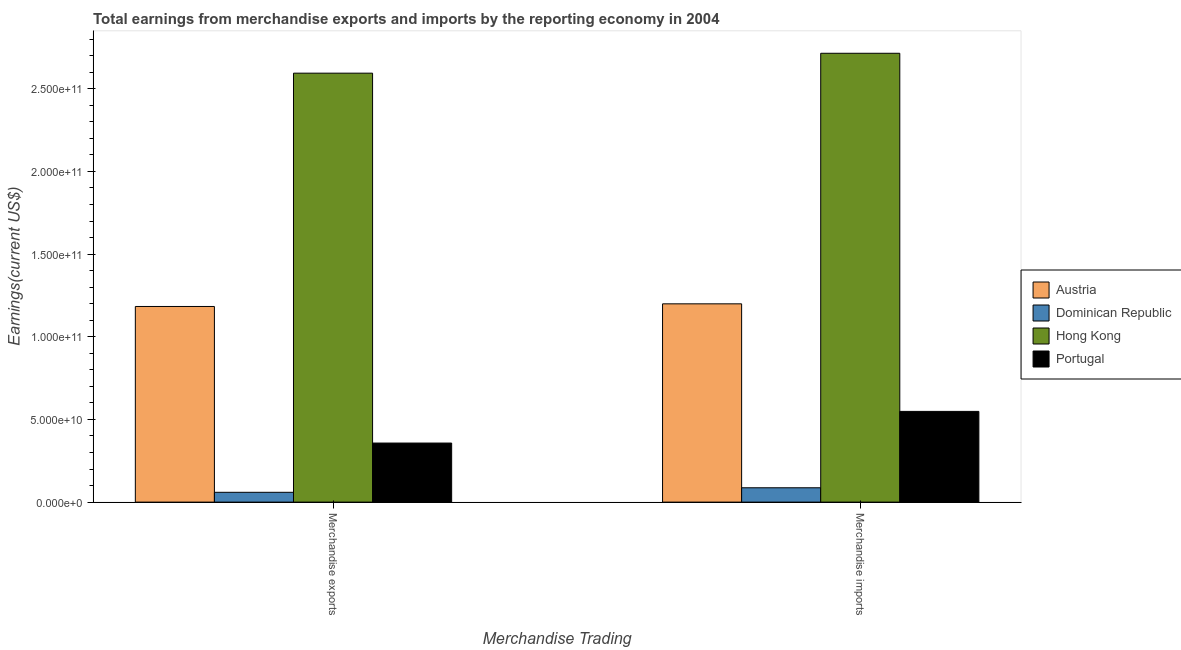Are the number of bars per tick equal to the number of legend labels?
Provide a succinct answer. Yes. How many bars are there on the 1st tick from the left?
Provide a short and direct response. 4. What is the label of the 1st group of bars from the left?
Offer a very short reply. Merchandise exports. What is the earnings from merchandise exports in Portugal?
Provide a succinct answer. 3.57e+1. Across all countries, what is the maximum earnings from merchandise exports?
Provide a short and direct response. 2.59e+11. Across all countries, what is the minimum earnings from merchandise exports?
Keep it short and to the point. 5.94e+09. In which country was the earnings from merchandise exports maximum?
Offer a terse response. Hong Kong. In which country was the earnings from merchandise imports minimum?
Give a very brief answer. Dominican Republic. What is the total earnings from merchandise exports in the graph?
Keep it short and to the point. 4.19e+11. What is the difference between the earnings from merchandise exports in Austria and that in Portugal?
Offer a very short reply. 8.26e+1. What is the difference between the earnings from merchandise exports in Hong Kong and the earnings from merchandise imports in Portugal?
Ensure brevity in your answer.  2.05e+11. What is the average earnings from merchandise imports per country?
Offer a very short reply. 1.14e+11. What is the difference between the earnings from merchandise exports and earnings from merchandise imports in Austria?
Your answer should be compact. -1.60e+09. What is the ratio of the earnings from merchandise imports in Austria to that in Dominican Republic?
Your answer should be compact. 13.82. Is the earnings from merchandise exports in Hong Kong less than that in Dominican Republic?
Keep it short and to the point. No. What does the 3rd bar from the left in Merchandise exports represents?
Keep it short and to the point. Hong Kong. What does the 3rd bar from the right in Merchandise exports represents?
Your answer should be very brief. Dominican Republic. How many bars are there?
Keep it short and to the point. 8. Are all the bars in the graph horizontal?
Offer a very short reply. No. Are the values on the major ticks of Y-axis written in scientific E-notation?
Offer a terse response. Yes. Does the graph contain grids?
Keep it short and to the point. No. Where does the legend appear in the graph?
Provide a short and direct response. Center right. What is the title of the graph?
Provide a succinct answer. Total earnings from merchandise exports and imports by the reporting economy in 2004. Does "Bahrain" appear as one of the legend labels in the graph?
Offer a terse response. No. What is the label or title of the X-axis?
Your answer should be very brief. Merchandise Trading. What is the label or title of the Y-axis?
Your answer should be very brief. Earnings(current US$). What is the Earnings(current US$) in Austria in Merchandise exports?
Your response must be concise. 1.18e+11. What is the Earnings(current US$) in Dominican Republic in Merchandise exports?
Your answer should be compact. 5.94e+09. What is the Earnings(current US$) in Hong Kong in Merchandise exports?
Provide a short and direct response. 2.59e+11. What is the Earnings(current US$) in Portugal in Merchandise exports?
Keep it short and to the point. 3.57e+1. What is the Earnings(current US$) in Austria in Merchandise imports?
Give a very brief answer. 1.20e+11. What is the Earnings(current US$) of Dominican Republic in Merchandise imports?
Provide a short and direct response. 8.68e+09. What is the Earnings(current US$) of Hong Kong in Merchandise imports?
Your answer should be very brief. 2.71e+11. What is the Earnings(current US$) in Portugal in Merchandise imports?
Offer a terse response. 5.49e+1. Across all Merchandise Trading, what is the maximum Earnings(current US$) in Austria?
Give a very brief answer. 1.20e+11. Across all Merchandise Trading, what is the maximum Earnings(current US$) in Dominican Republic?
Offer a very short reply. 8.68e+09. Across all Merchandise Trading, what is the maximum Earnings(current US$) in Hong Kong?
Ensure brevity in your answer.  2.71e+11. Across all Merchandise Trading, what is the maximum Earnings(current US$) of Portugal?
Provide a short and direct response. 5.49e+1. Across all Merchandise Trading, what is the minimum Earnings(current US$) in Austria?
Your response must be concise. 1.18e+11. Across all Merchandise Trading, what is the minimum Earnings(current US$) of Dominican Republic?
Offer a very short reply. 5.94e+09. Across all Merchandise Trading, what is the minimum Earnings(current US$) of Hong Kong?
Your answer should be very brief. 2.59e+11. Across all Merchandise Trading, what is the minimum Earnings(current US$) of Portugal?
Provide a succinct answer. 3.57e+1. What is the total Earnings(current US$) in Austria in the graph?
Your answer should be very brief. 2.38e+11. What is the total Earnings(current US$) in Dominican Republic in the graph?
Keep it short and to the point. 1.46e+1. What is the total Earnings(current US$) of Hong Kong in the graph?
Your response must be concise. 5.31e+11. What is the total Earnings(current US$) of Portugal in the graph?
Ensure brevity in your answer.  9.06e+1. What is the difference between the Earnings(current US$) in Austria in Merchandise exports and that in Merchandise imports?
Give a very brief answer. -1.60e+09. What is the difference between the Earnings(current US$) in Dominican Republic in Merchandise exports and that in Merchandise imports?
Offer a terse response. -2.74e+09. What is the difference between the Earnings(current US$) of Hong Kong in Merchandise exports and that in Merchandise imports?
Your response must be concise. -1.20e+1. What is the difference between the Earnings(current US$) of Portugal in Merchandise exports and that in Merchandise imports?
Keep it short and to the point. -1.91e+1. What is the difference between the Earnings(current US$) in Austria in Merchandise exports and the Earnings(current US$) in Dominican Republic in Merchandise imports?
Give a very brief answer. 1.10e+11. What is the difference between the Earnings(current US$) in Austria in Merchandise exports and the Earnings(current US$) in Hong Kong in Merchandise imports?
Your answer should be compact. -1.53e+11. What is the difference between the Earnings(current US$) in Austria in Merchandise exports and the Earnings(current US$) in Portugal in Merchandise imports?
Offer a terse response. 6.35e+1. What is the difference between the Earnings(current US$) of Dominican Republic in Merchandise exports and the Earnings(current US$) of Hong Kong in Merchandise imports?
Provide a short and direct response. -2.66e+11. What is the difference between the Earnings(current US$) of Dominican Republic in Merchandise exports and the Earnings(current US$) of Portugal in Merchandise imports?
Provide a short and direct response. -4.89e+1. What is the difference between the Earnings(current US$) of Hong Kong in Merchandise exports and the Earnings(current US$) of Portugal in Merchandise imports?
Your answer should be very brief. 2.05e+11. What is the average Earnings(current US$) in Austria per Merchandise Trading?
Ensure brevity in your answer.  1.19e+11. What is the average Earnings(current US$) in Dominican Republic per Merchandise Trading?
Your answer should be very brief. 7.31e+09. What is the average Earnings(current US$) in Hong Kong per Merchandise Trading?
Offer a terse response. 2.65e+11. What is the average Earnings(current US$) in Portugal per Merchandise Trading?
Offer a very short reply. 4.53e+1. What is the difference between the Earnings(current US$) of Austria and Earnings(current US$) of Dominican Republic in Merchandise exports?
Provide a short and direct response. 1.12e+11. What is the difference between the Earnings(current US$) of Austria and Earnings(current US$) of Hong Kong in Merchandise exports?
Ensure brevity in your answer.  -1.41e+11. What is the difference between the Earnings(current US$) in Austria and Earnings(current US$) in Portugal in Merchandise exports?
Offer a terse response. 8.26e+1. What is the difference between the Earnings(current US$) of Dominican Republic and Earnings(current US$) of Hong Kong in Merchandise exports?
Offer a terse response. -2.53e+11. What is the difference between the Earnings(current US$) of Dominican Republic and Earnings(current US$) of Portugal in Merchandise exports?
Give a very brief answer. -2.98e+1. What is the difference between the Earnings(current US$) in Hong Kong and Earnings(current US$) in Portugal in Merchandise exports?
Make the answer very short. 2.24e+11. What is the difference between the Earnings(current US$) of Austria and Earnings(current US$) of Dominican Republic in Merchandise imports?
Provide a short and direct response. 1.11e+11. What is the difference between the Earnings(current US$) of Austria and Earnings(current US$) of Hong Kong in Merchandise imports?
Offer a terse response. -1.52e+11. What is the difference between the Earnings(current US$) of Austria and Earnings(current US$) of Portugal in Merchandise imports?
Offer a terse response. 6.51e+1. What is the difference between the Earnings(current US$) in Dominican Republic and Earnings(current US$) in Hong Kong in Merchandise imports?
Offer a terse response. -2.63e+11. What is the difference between the Earnings(current US$) in Dominican Republic and Earnings(current US$) in Portugal in Merchandise imports?
Your response must be concise. -4.62e+1. What is the difference between the Earnings(current US$) of Hong Kong and Earnings(current US$) of Portugal in Merchandise imports?
Offer a very short reply. 2.17e+11. What is the ratio of the Earnings(current US$) in Austria in Merchandise exports to that in Merchandise imports?
Provide a short and direct response. 0.99. What is the ratio of the Earnings(current US$) in Dominican Republic in Merchandise exports to that in Merchandise imports?
Provide a short and direct response. 0.68. What is the ratio of the Earnings(current US$) in Hong Kong in Merchandise exports to that in Merchandise imports?
Offer a very short reply. 0.96. What is the ratio of the Earnings(current US$) of Portugal in Merchandise exports to that in Merchandise imports?
Offer a very short reply. 0.65. What is the difference between the highest and the second highest Earnings(current US$) in Austria?
Make the answer very short. 1.60e+09. What is the difference between the highest and the second highest Earnings(current US$) in Dominican Republic?
Offer a very short reply. 2.74e+09. What is the difference between the highest and the second highest Earnings(current US$) of Hong Kong?
Offer a terse response. 1.20e+1. What is the difference between the highest and the second highest Earnings(current US$) in Portugal?
Ensure brevity in your answer.  1.91e+1. What is the difference between the highest and the lowest Earnings(current US$) of Austria?
Ensure brevity in your answer.  1.60e+09. What is the difference between the highest and the lowest Earnings(current US$) of Dominican Republic?
Provide a short and direct response. 2.74e+09. What is the difference between the highest and the lowest Earnings(current US$) of Hong Kong?
Keep it short and to the point. 1.20e+1. What is the difference between the highest and the lowest Earnings(current US$) of Portugal?
Make the answer very short. 1.91e+1. 